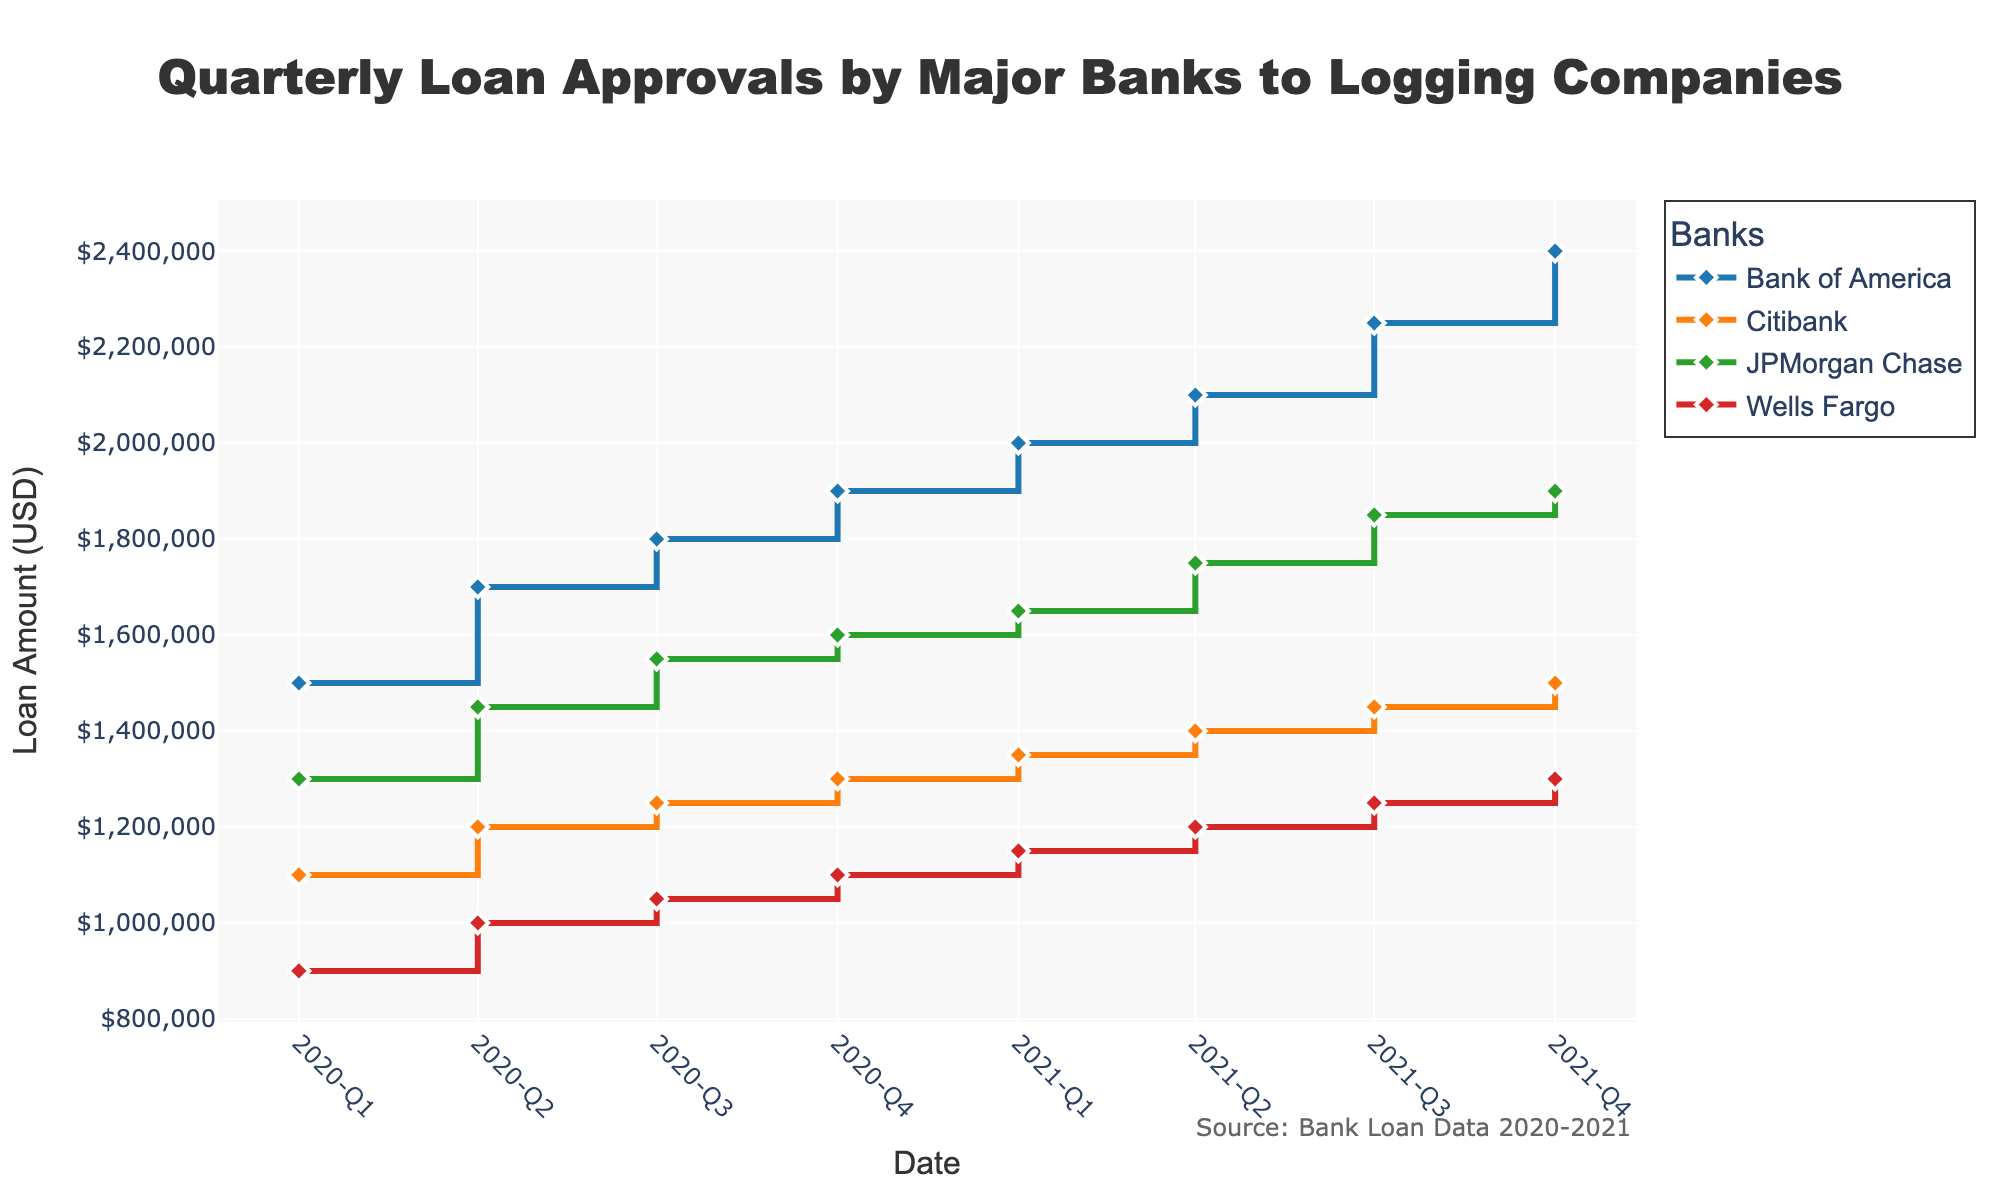What is the title of the figure? The title of the figure is located at the top of the plot and provides an overview of what the figure represents. It reads, "Quarterly Loan Approvals by Major Banks to Logging Companies."
Answer: Quarterly Loan Approvals by Major Banks to Logging Companies How many banks are represented in the figure? The figure has a legend that categorizes the data by banks, listing each bank with a different color and line style. There are four banks represented.
Answer: Four What is the highest loan amount approved by Bank of America in this timeframe? By observing the highest point on the 'Bank of America' line, which is represented in blue, at any point along the y-axis, you can see the highest loan amount. The highest point is $2.4 million.
Answer: $2,400,000 Which bank shows the least growth in loan amount from Q1 2020 to Q4 2021? To determine the bank with the least growth, you need to compare the starting and ending points of each bank's line on the plot. Citibank, indicated in green, grows only from $1.1 million to $1.5 million, the smallest increment compared to the other banks.
Answer: Citibank What is the total loan amount approved by all banks in Q2 2020? To find the total for a specific quarter, sum the loan amounts for all banks in that quarter. For Q2 2020, the amounts are: Bank of America ($1.7 million), JPMorgan Chase ($1.45 million), Citibank ($1.2 million), and Wells Fargo ($1.0 million). The total is $5.35 million.
Answer: $5,350,000 Which bank had the highest loan amount approved in Q1 2021, and what was the amount? Look specifically at the data points for Q1 2021. Bank of America has the highest point compared to the others, with an amount of $2 million.
Answer: Bank of America, $2,000,000 How does the loan approval trend for Wells Fargo compare between Q1 2020 and Q4 2021? Trace the line representing Wells Fargo from Q1 2020 to Q4 2021. The loan amount increases gradually over time from $0.9 million to $1.3 million, showing a consistent upward trend.
Answer: Gradually increases What is the average loan approval amount for all banks in Q3 2021? Calculate the average by summing the loan amounts for Q3 2021 and dividing by the number of banks. The amounts are: Bank of America ($2.25 million), JPMorgan Chase ($1.85 million), Citibank ($1.45 million), Wells Fargo ($1.25 million). The sum is $6.8 million. Divided by 4, the average is $1.7 million.
Answer: $1,700,000 Compare the loan amounts approved by JPMorgan Chase and Citibank in Q4 2020. Who approved more, and by how much? Look at the data points for Q4 2020 for both banks. JPMorgan Chase's loan amount is $1.6 million, and Citibank's is $1.3 million. Subtract Citibank’s amount from JPMorgan Chase’s to find the difference: $1.6 million - $1.3 million = $0.3 million.
Answer: JPMorgan Chase, $0.3 million 